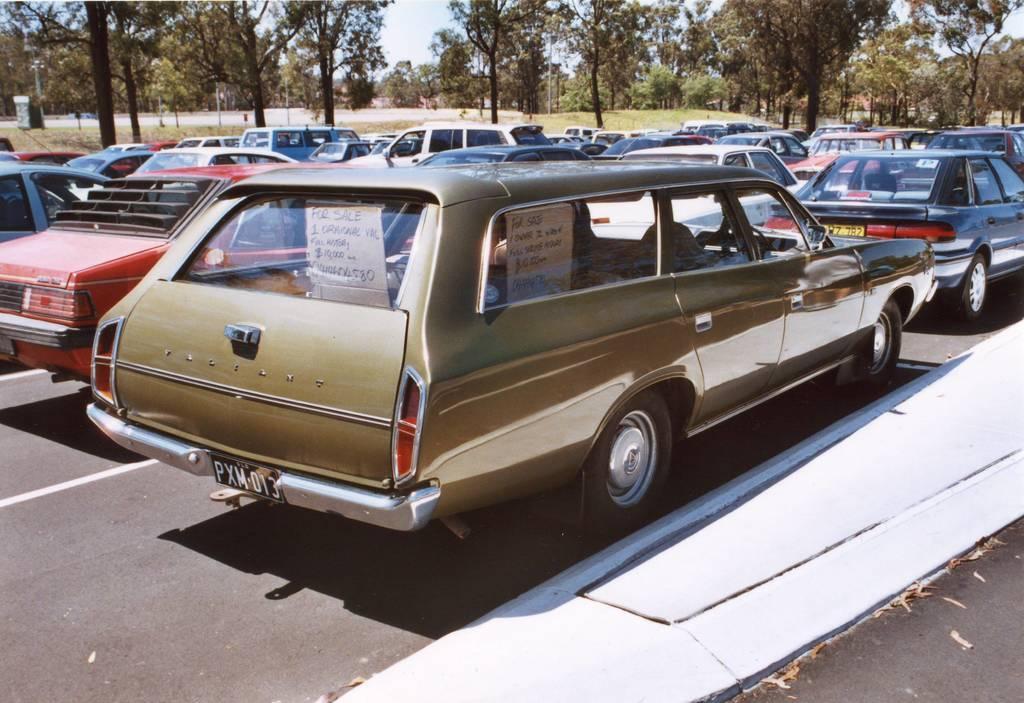Can you describe this image briefly? In this image, we can see vehicles on the road and in the background, there are trees, poles and boards. At the top, there is sky. 